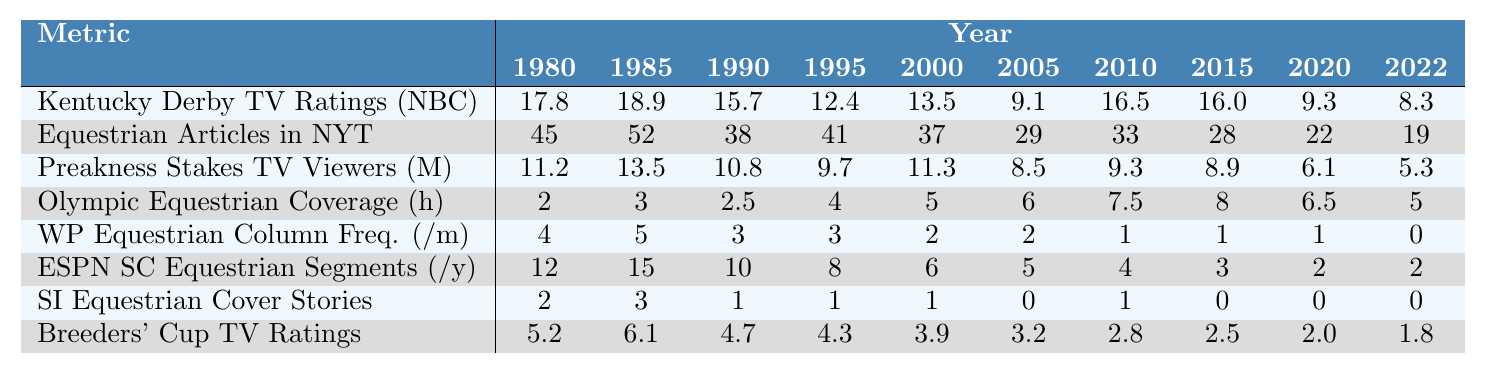What was the peak Kentucky Derby TV rating recorded between 1980 and 2022? The table shows the Kentucky Derby TV ratings for each year. By examining the values, the highest rating is 18.9 in 1985.
Answer: 18.9 In which year did the Washington Post have the highest frequency of equestrian columns? From the data, the Washington Post Equestrian Column Frequency peaked at 5 per month in 1985.
Answer: 5 What is the difference in Olympic equestrian coverage hours between 2000 and 2022? The coverage hours in 2000 is 5, and in 2022 it's 5. The difference is 5 - 5 = 0.
Answer: 0 How many equestrian articles were published in the New York Times in 1990? The table shows that there were 38 articles published in the New York Times in 1990.
Answer: 38 Which year had the lowest viewership for the Preakness Stakes? By reviewing the Preakness Stakes TV viewers' statistics, 2022 had the lowest viewership, with 5.3 million viewers.
Answer: 2022 Calculate the average number of ESPN SportsCenter segments per year from 1980 to 2022. The sum of the segments is (12 + 15 + 10 + 8 + 6 + 5 + 4 + 3 + 2 + 2) = 67. The average is 67 divided by 10 years = 6.7 segments/year.
Answer: 6.7 Was there a year when no equestrian cover stories were reported in Sports Illustrated? Checking the data, Sports Illustrated had no equestrian cover stories in 2005, 2015, 2020, and 2022, so the answer is yes.
Answer: Yes Between which two years was there a significant increase in Olympic equestrian coverage hours? The hours increased from 5 in 2000 to 8 in 2015, which is the most significant increase within the given years.
Answer: 2000 and 2015 What was the average Breeders' Cup TV rating from 1980 to 2022? Summing the TV ratings gives (5.2 + 6.1 + 4.7 + 4.3 + 3.9 + 3.2 + 2.8 + 2.5 + 2.0 + 1.8) = 34.5. Dividing by 10 years gives an average of 3.45.
Answer: 3.45 In which year did the Kentucky Derby TV ratings show the most significant decline from the previous year? The largest drop occurred from 2010 (16.5) to 2011 (16.0), a decline of 0.5.
Answer: 2011 